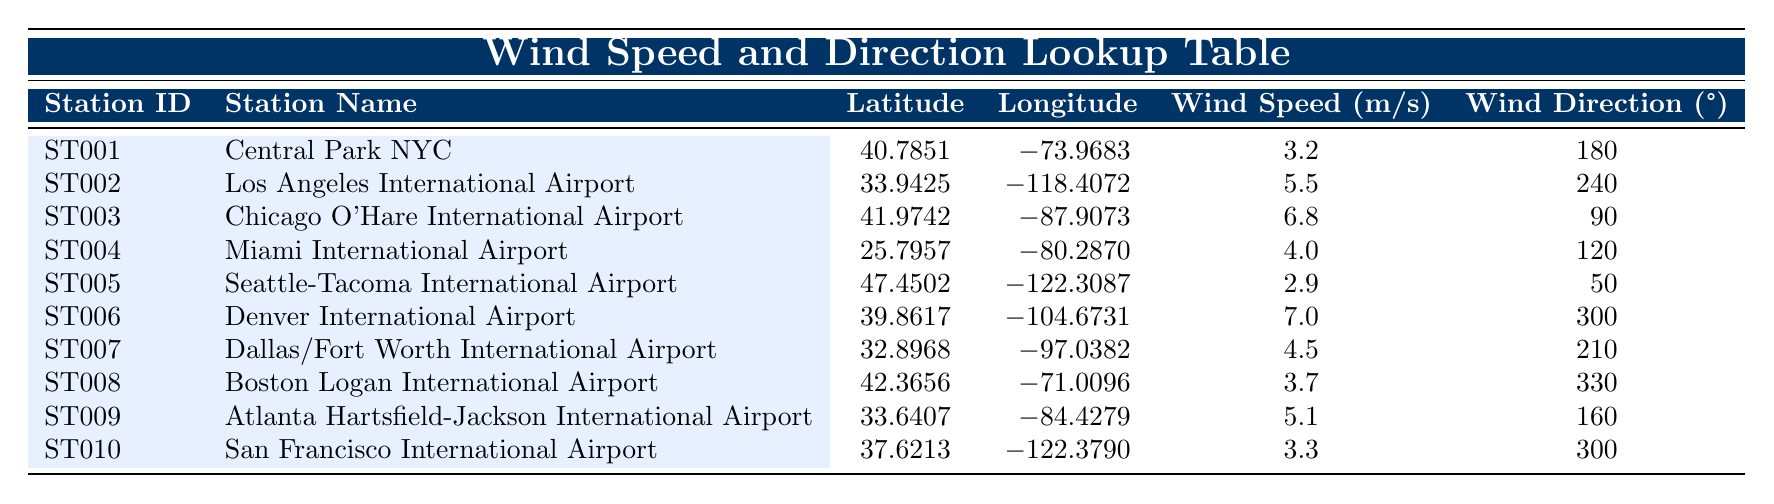What is the wind speed measured at Chicago O'Hare International Airport? The wind speed is listed under the "Wind Speed (m/s)" column for the entry corresponding to "Chicago O'Hare International Airport." According to the table, the value is 6.8 m/s.
Answer: 6.8 m/s Which station recorded the highest wind speed? To find the station with the highest wind speed, I will compare the values in the "Wind Speed (m/s)" column. The highest value is 7.0 m/s recorded at "Denver International Airport."
Answer: Denver International Airport What is the average wind speed of the stations listed in the table? First, I will sum all the wind speed values: (3.2 + 5.5 + 6.8 + 4.0 + 2.9 + 7.0 + 4.5 + 3.7 + 5.1 + 3.3) = 46.0 m/s. There are 10 stations, so I divide the total by 10: 46.0 / 10 = 4.6 m/s.
Answer: 4.6 m/s Is there a station located at a latitude greater than 40 degrees? I need to look at the "Latitude" column and identify any values greater than 40. There are three stations, Central Park NYC (40.7851), Chicago O'Hare International Airport (41.9742), and Seattle-Tacoma International Airport (47.4502), that satisfy this condition. Therefore, the answer is yes.
Answer: Yes What is the average wind direction for the stations located in the eastern part of the United States (east of longitude -90)? The stations located east of longitude -90 are Central Park NYC, Miami International Airport, Boston Logan International Airport, and Atlanta Hartsfield-Jackson International Airport. Their wind directions are 180°, 120°, 330°, and 160°, respectively. The average is calculated as follows: (180 + 120 + 330 + 160) / 4 = 197.5°.
Answer: 197.5° Which station's wind direction is closest to north? To determine which station's wind direction is closest to north (0° or 360°), I will check the "Wind Direction (°)" column. The station with the value closest to 0° is Seattle-Tacoma International Airport at 50°, as it is the smallest angle away from north.
Answer: Seattle-Tacoma International Airport How many stations have a wind speed greater than 5 m/s? I will count the entries in the "Wind Speed (m/s)" column that exceed 5 m/s. The stations with higher wind speeds are Los Angeles International Airport (5.5 m/s), Chicago O'Hare International Airport (6.8 m/s), and Denver International Airport (7.0 m/s), making a total of three stations.
Answer: 3 Is the wind speed at San Francisco International Airport greater than that at Miami International Airport? The wind speed at San Francisco International Airport is 3.3 m/s, and at Miami International Airport, it is 4.0 m/s. Since 3.3 m/s is not greater than 4.0 m/s, the answer is no.
Answer: No 